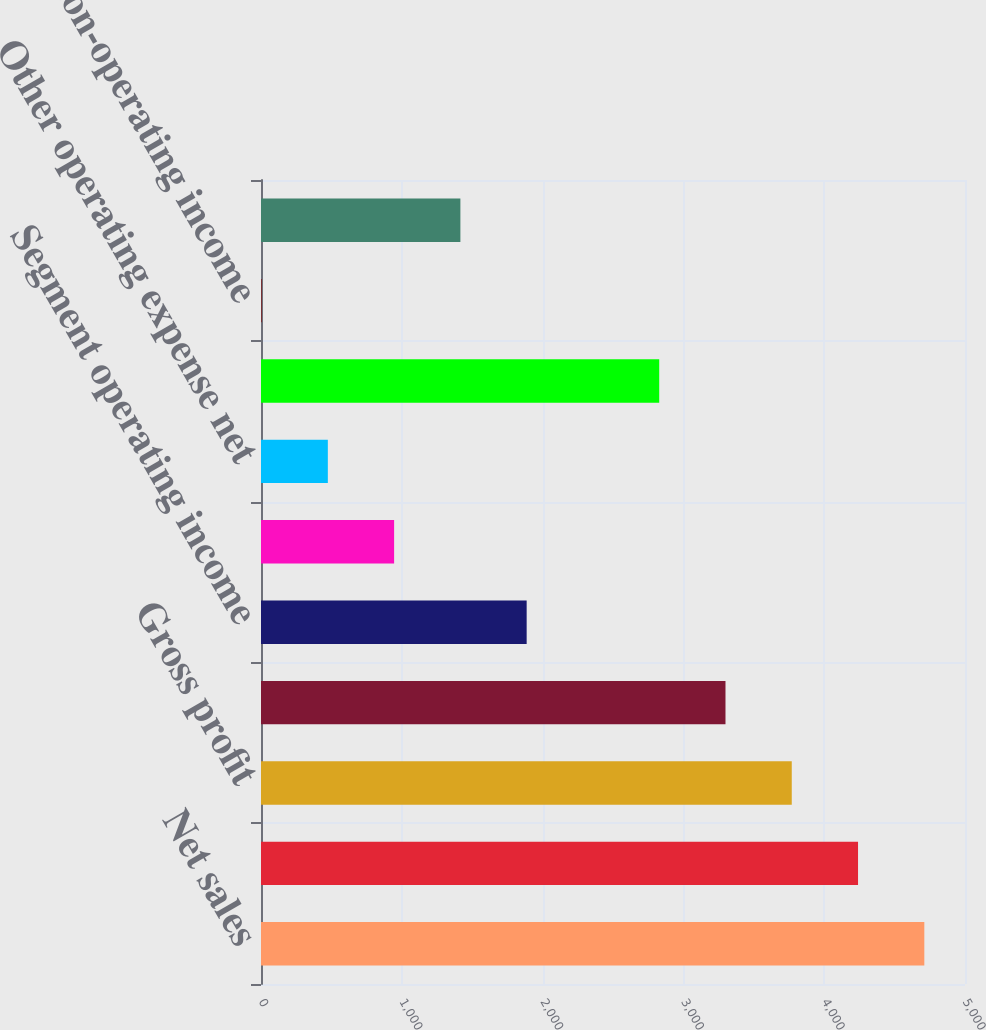<chart> <loc_0><loc_0><loc_500><loc_500><bar_chart><fcel>Net sales<fcel>Cost of sales<fcel>Gross profit<fcel>Direct segment operating<fcel>Segment operating income<fcel>Stock-based compensation<fcel>Other operating expense net<fcel>Income from operations<fcel>Total non-operating income<fcel>Provision for income taxes<nl><fcel>4711<fcel>4240.3<fcel>3769.6<fcel>3298.9<fcel>1886.8<fcel>945.4<fcel>474.7<fcel>2828.2<fcel>4<fcel>1416.1<nl></chart> 